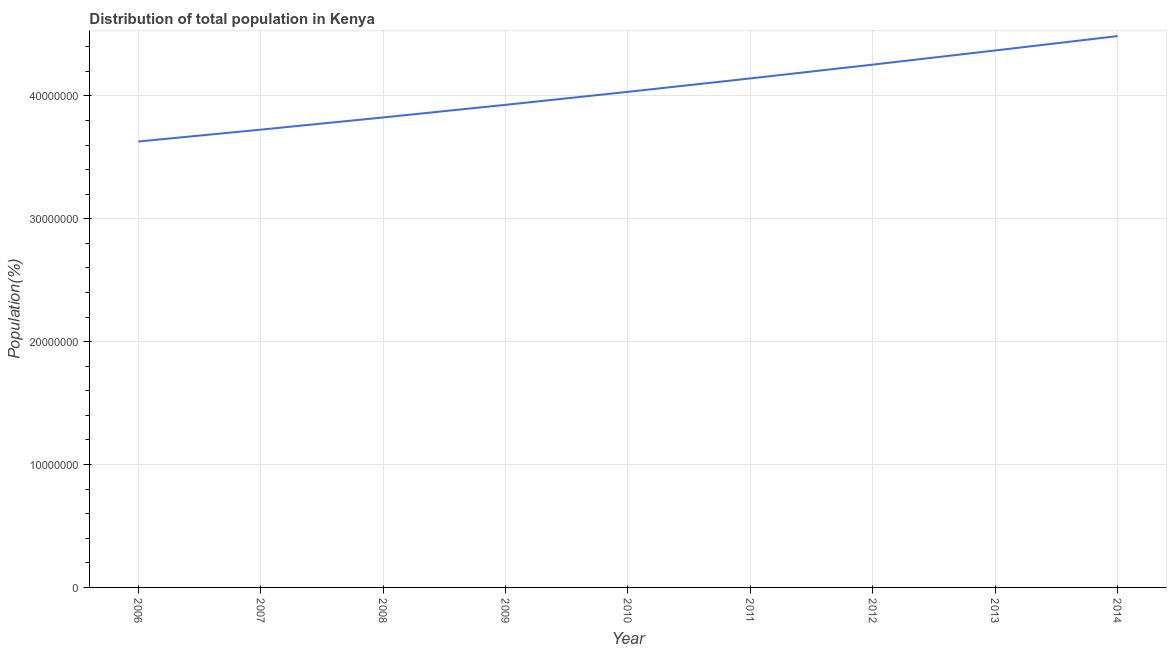What is the population in 2014?
Offer a very short reply. 4.49e+07. Across all years, what is the maximum population?
Ensure brevity in your answer.  4.49e+07. Across all years, what is the minimum population?
Offer a very short reply. 3.63e+07. What is the sum of the population?
Ensure brevity in your answer.  3.64e+08. What is the difference between the population in 2009 and 2010?
Your answer should be very brief. -1.06e+06. What is the average population per year?
Your answer should be compact. 4.04e+07. What is the median population?
Keep it short and to the point. 4.03e+07. In how many years, is the population greater than 4000000 %?
Keep it short and to the point. 9. What is the ratio of the population in 2007 to that in 2009?
Keep it short and to the point. 0.95. What is the difference between the highest and the second highest population?
Offer a terse response. 1.17e+06. What is the difference between the highest and the lowest population?
Your answer should be compact. 8.58e+06. In how many years, is the population greater than the average population taken over all years?
Your response must be concise. 4. Does the population monotonically increase over the years?
Make the answer very short. Yes. How many lines are there?
Your response must be concise. 1. What is the difference between two consecutive major ticks on the Y-axis?
Your answer should be very brief. 1.00e+07. Are the values on the major ticks of Y-axis written in scientific E-notation?
Provide a short and direct response. No. Does the graph contain any zero values?
Give a very brief answer. No. Does the graph contain grids?
Your response must be concise. Yes. What is the title of the graph?
Provide a succinct answer. Distribution of total population in Kenya . What is the label or title of the X-axis?
Offer a terse response. Year. What is the label or title of the Y-axis?
Your answer should be very brief. Population(%). What is the Population(%) in 2006?
Keep it short and to the point. 3.63e+07. What is the Population(%) in 2007?
Ensure brevity in your answer.  3.73e+07. What is the Population(%) of 2008?
Offer a very short reply. 3.82e+07. What is the Population(%) in 2009?
Offer a terse response. 3.93e+07. What is the Population(%) of 2010?
Make the answer very short. 4.03e+07. What is the Population(%) of 2011?
Ensure brevity in your answer.  4.14e+07. What is the Population(%) of 2012?
Your response must be concise. 4.25e+07. What is the Population(%) of 2013?
Your response must be concise. 4.37e+07. What is the Population(%) in 2014?
Your response must be concise. 4.49e+07. What is the difference between the Population(%) in 2006 and 2007?
Ensure brevity in your answer.  -9.65e+05. What is the difference between the Population(%) in 2006 and 2008?
Keep it short and to the point. -1.96e+06. What is the difference between the Population(%) in 2006 and 2009?
Offer a very short reply. -2.98e+06. What is the difference between the Population(%) in 2006 and 2010?
Your answer should be very brief. -4.04e+06. What is the difference between the Population(%) in 2006 and 2011?
Give a very brief answer. -5.13e+06. What is the difference between the Population(%) in 2006 and 2012?
Make the answer very short. -6.26e+06. What is the difference between the Population(%) in 2006 and 2013?
Ensure brevity in your answer.  -7.41e+06. What is the difference between the Population(%) in 2006 and 2014?
Make the answer very short. -8.58e+06. What is the difference between the Population(%) in 2007 and 2008?
Offer a terse response. -9.94e+05. What is the difference between the Population(%) in 2007 and 2009?
Ensure brevity in your answer.  -2.02e+06. What is the difference between the Population(%) in 2007 and 2010?
Your answer should be compact. -3.08e+06. What is the difference between the Population(%) in 2007 and 2011?
Your response must be concise. -4.17e+06. What is the difference between the Population(%) in 2007 and 2012?
Offer a terse response. -5.29e+06. What is the difference between the Population(%) in 2007 and 2013?
Offer a very short reply. -6.44e+06. What is the difference between the Population(%) in 2007 and 2014?
Offer a very short reply. -7.61e+06. What is the difference between the Population(%) in 2008 and 2009?
Your answer should be compact. -1.03e+06. What is the difference between the Population(%) in 2008 and 2010?
Your answer should be very brief. -2.08e+06. What is the difference between the Population(%) in 2008 and 2011?
Your answer should be compact. -3.18e+06. What is the difference between the Population(%) in 2008 and 2012?
Offer a terse response. -4.30e+06. What is the difference between the Population(%) in 2008 and 2013?
Make the answer very short. -5.45e+06. What is the difference between the Population(%) in 2008 and 2014?
Offer a terse response. -6.62e+06. What is the difference between the Population(%) in 2009 and 2010?
Make the answer very short. -1.06e+06. What is the difference between the Population(%) in 2009 and 2011?
Offer a terse response. -2.15e+06. What is the difference between the Population(%) in 2009 and 2012?
Offer a terse response. -3.27e+06. What is the difference between the Population(%) in 2009 and 2013?
Provide a short and direct response. -4.42e+06. What is the difference between the Population(%) in 2009 and 2014?
Provide a short and direct response. -5.59e+06. What is the difference between the Population(%) in 2010 and 2011?
Offer a very short reply. -1.09e+06. What is the difference between the Population(%) in 2010 and 2012?
Your response must be concise. -2.21e+06. What is the difference between the Population(%) in 2010 and 2013?
Your answer should be very brief. -3.36e+06. What is the difference between the Population(%) in 2010 and 2014?
Your answer should be very brief. -4.54e+06. What is the difference between the Population(%) in 2011 and 2012?
Provide a succinct answer. -1.12e+06. What is the difference between the Population(%) in 2011 and 2013?
Your response must be concise. -2.27e+06. What is the difference between the Population(%) in 2011 and 2014?
Your answer should be compact. -3.44e+06. What is the difference between the Population(%) in 2012 and 2013?
Offer a terse response. -1.15e+06. What is the difference between the Population(%) in 2012 and 2014?
Keep it short and to the point. -2.32e+06. What is the difference between the Population(%) in 2013 and 2014?
Offer a very short reply. -1.17e+06. What is the ratio of the Population(%) in 2006 to that in 2007?
Offer a terse response. 0.97. What is the ratio of the Population(%) in 2006 to that in 2008?
Provide a short and direct response. 0.95. What is the ratio of the Population(%) in 2006 to that in 2009?
Provide a short and direct response. 0.92. What is the ratio of the Population(%) in 2006 to that in 2011?
Offer a very short reply. 0.88. What is the ratio of the Population(%) in 2006 to that in 2012?
Provide a short and direct response. 0.85. What is the ratio of the Population(%) in 2006 to that in 2013?
Make the answer very short. 0.83. What is the ratio of the Population(%) in 2006 to that in 2014?
Provide a short and direct response. 0.81. What is the ratio of the Population(%) in 2007 to that in 2009?
Your response must be concise. 0.95. What is the ratio of the Population(%) in 2007 to that in 2010?
Make the answer very short. 0.92. What is the ratio of the Population(%) in 2007 to that in 2011?
Provide a succinct answer. 0.9. What is the ratio of the Population(%) in 2007 to that in 2012?
Offer a terse response. 0.88. What is the ratio of the Population(%) in 2007 to that in 2013?
Give a very brief answer. 0.85. What is the ratio of the Population(%) in 2007 to that in 2014?
Give a very brief answer. 0.83. What is the ratio of the Population(%) in 2008 to that in 2010?
Your answer should be very brief. 0.95. What is the ratio of the Population(%) in 2008 to that in 2011?
Offer a very short reply. 0.92. What is the ratio of the Population(%) in 2008 to that in 2012?
Your answer should be very brief. 0.9. What is the ratio of the Population(%) in 2008 to that in 2014?
Your answer should be very brief. 0.85. What is the ratio of the Population(%) in 2009 to that in 2010?
Your answer should be very brief. 0.97. What is the ratio of the Population(%) in 2009 to that in 2011?
Provide a short and direct response. 0.95. What is the ratio of the Population(%) in 2009 to that in 2012?
Provide a short and direct response. 0.92. What is the ratio of the Population(%) in 2009 to that in 2013?
Make the answer very short. 0.9. What is the ratio of the Population(%) in 2010 to that in 2011?
Offer a terse response. 0.97. What is the ratio of the Population(%) in 2010 to that in 2012?
Your answer should be very brief. 0.95. What is the ratio of the Population(%) in 2010 to that in 2013?
Your response must be concise. 0.92. What is the ratio of the Population(%) in 2010 to that in 2014?
Offer a terse response. 0.9. What is the ratio of the Population(%) in 2011 to that in 2013?
Keep it short and to the point. 0.95. What is the ratio of the Population(%) in 2011 to that in 2014?
Your response must be concise. 0.92. What is the ratio of the Population(%) in 2012 to that in 2014?
Offer a very short reply. 0.95. What is the ratio of the Population(%) in 2013 to that in 2014?
Your answer should be very brief. 0.97. 